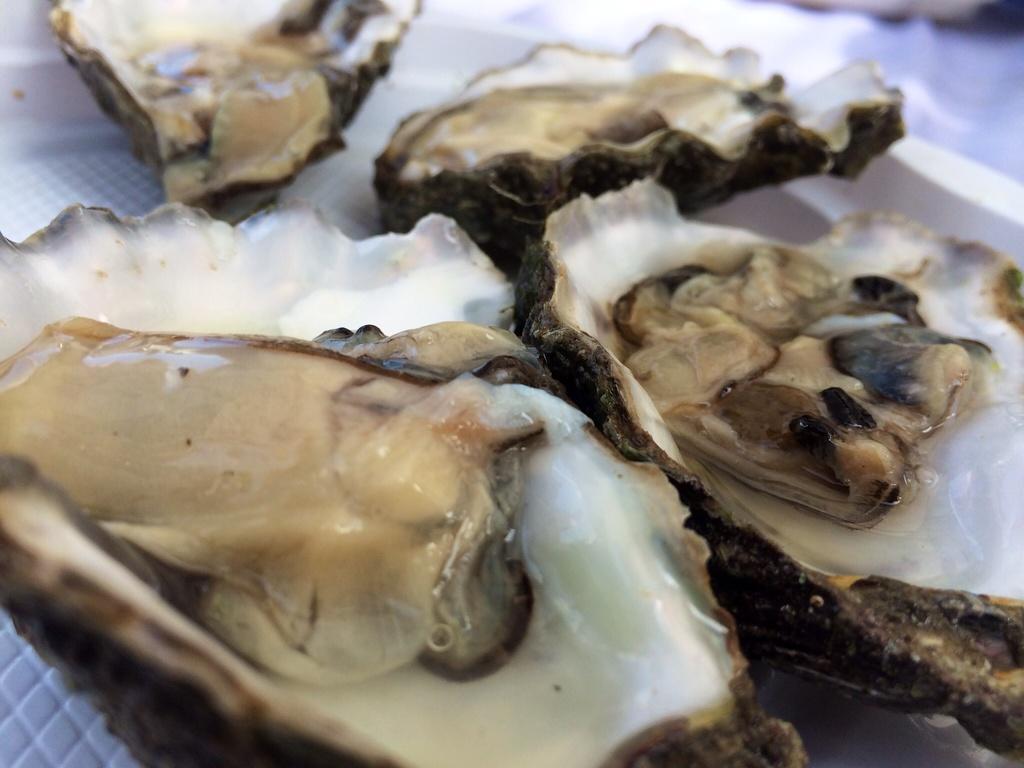Please provide a concise description of this image. In the picture we can see some raw oysters. 